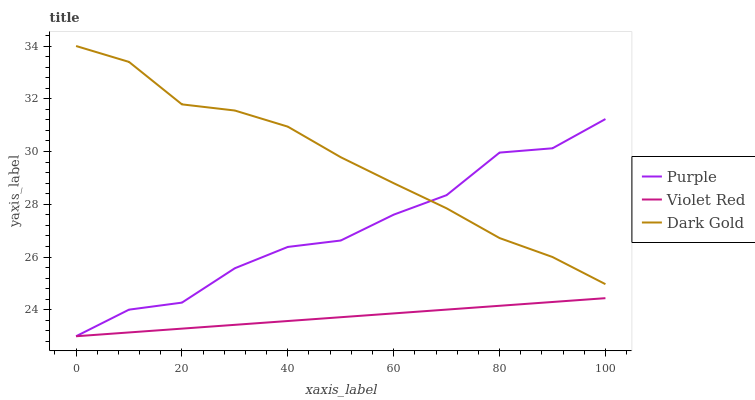Does Violet Red have the minimum area under the curve?
Answer yes or no. Yes. Does Dark Gold have the maximum area under the curve?
Answer yes or no. Yes. Does Dark Gold have the minimum area under the curve?
Answer yes or no. No. Does Violet Red have the maximum area under the curve?
Answer yes or no. No. Is Violet Red the smoothest?
Answer yes or no. Yes. Is Purple the roughest?
Answer yes or no. Yes. Is Dark Gold the smoothest?
Answer yes or no. No. Is Dark Gold the roughest?
Answer yes or no. No. Does Purple have the lowest value?
Answer yes or no. Yes. Does Dark Gold have the lowest value?
Answer yes or no. No. Does Dark Gold have the highest value?
Answer yes or no. Yes. Does Violet Red have the highest value?
Answer yes or no. No. Is Violet Red less than Dark Gold?
Answer yes or no. Yes. Is Dark Gold greater than Violet Red?
Answer yes or no. Yes. Does Violet Red intersect Purple?
Answer yes or no. Yes. Is Violet Red less than Purple?
Answer yes or no. No. Is Violet Red greater than Purple?
Answer yes or no. No. Does Violet Red intersect Dark Gold?
Answer yes or no. No. 